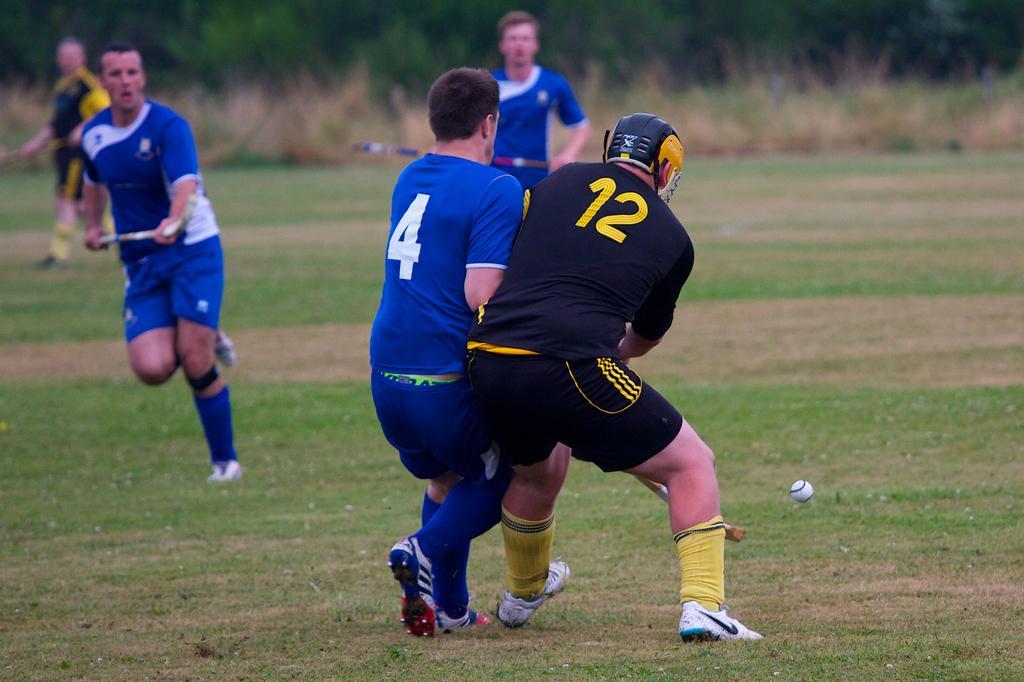Please provide a concise description of this image. In the image in the center we can see we can see one ball,few people were standing and they were holding some object. And they were in different color t shirt. In the background we can see trees,plants and grass. 